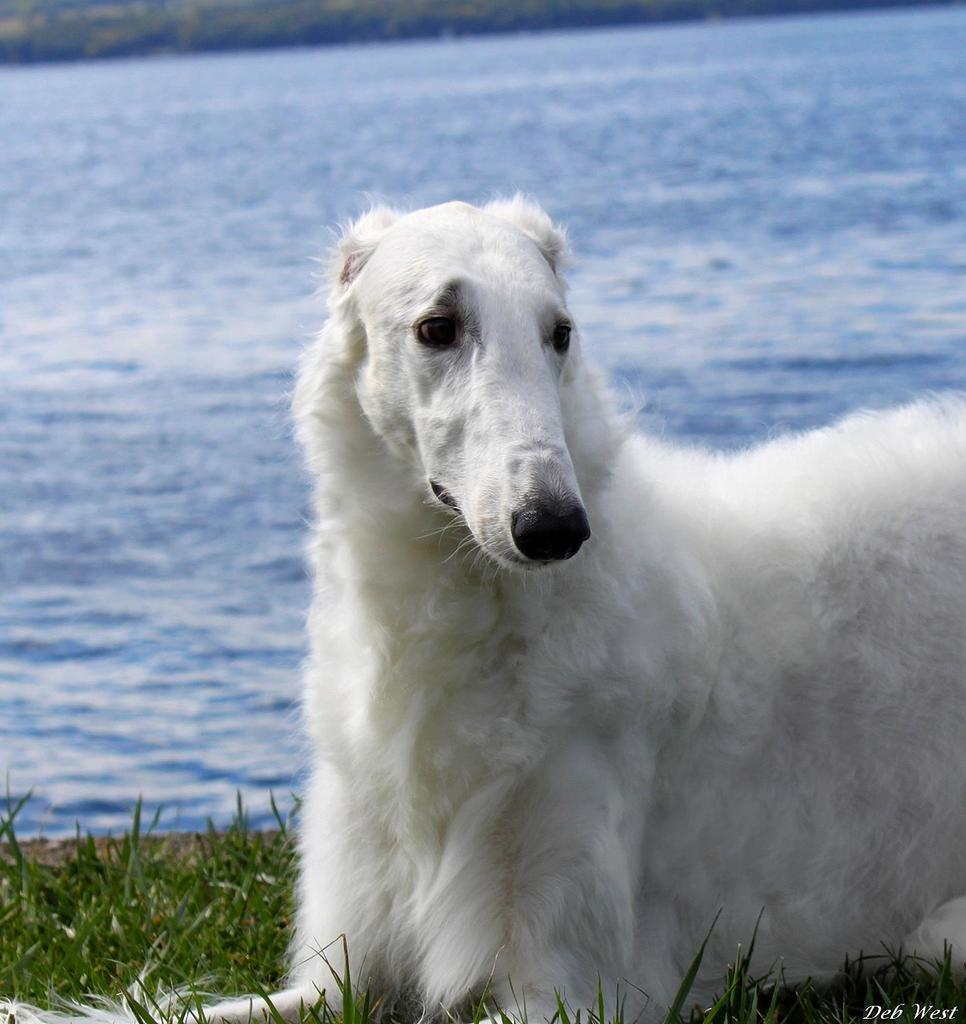What type of animal can be seen in the image? There is an animal in the image, but its specific type is not mentioned. What color is the animal in the image? The animal is white. What is the color of the grass in the background of the image? The grass in the background of the image is green. What color is the water in the image? The water in the image is blue. How many legs does the stranger have in the image? There is no stranger present in the image, so it is not possible to determine the number of legs they might have. 